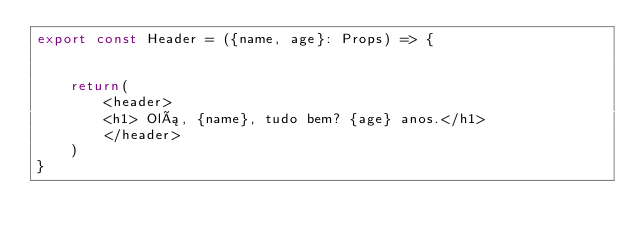Convert code to text. <code><loc_0><loc_0><loc_500><loc_500><_TypeScript_>export const Header = ({name, age}: Props) => {
    
    
    return(
        <header>
        <h1> Olá, {name}, tudo bem? {age} anos.</h1>
        </header>
    )
}</code> 